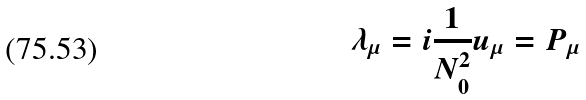<formula> <loc_0><loc_0><loc_500><loc_500>\lambda _ { \mu } = i \frac { 1 } { N _ { 0 } ^ { 2 } } u _ { \mu } = P _ { \mu }</formula> 